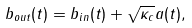Convert formula to latex. <formula><loc_0><loc_0><loc_500><loc_500>b _ { o u t } ( t ) = b _ { i n } ( t ) + \sqrt { \kappa _ { c } } a ( t ) ,</formula> 